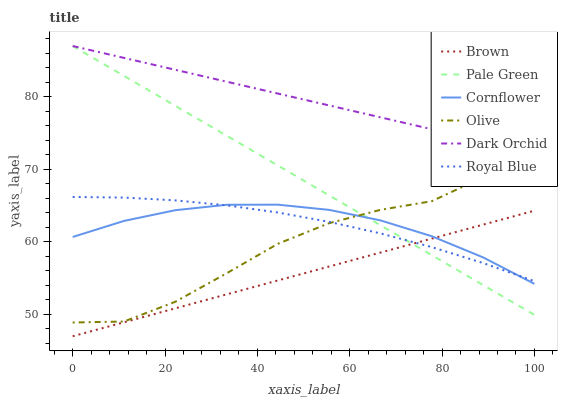Does Brown have the minimum area under the curve?
Answer yes or no. Yes. Does Dark Orchid have the maximum area under the curve?
Answer yes or no. Yes. Does Cornflower have the minimum area under the curve?
Answer yes or no. No. Does Cornflower have the maximum area under the curve?
Answer yes or no. No. Is Brown the smoothest?
Answer yes or no. Yes. Is Olive the roughest?
Answer yes or no. Yes. Is Cornflower the smoothest?
Answer yes or no. No. Is Cornflower the roughest?
Answer yes or no. No. Does Brown have the lowest value?
Answer yes or no. Yes. Does Cornflower have the lowest value?
Answer yes or no. No. Does Pale Green have the highest value?
Answer yes or no. Yes. Does Cornflower have the highest value?
Answer yes or no. No. Is Brown less than Olive?
Answer yes or no. Yes. Is Dark Orchid greater than Brown?
Answer yes or no. Yes. Does Royal Blue intersect Cornflower?
Answer yes or no. Yes. Is Royal Blue less than Cornflower?
Answer yes or no. No. Is Royal Blue greater than Cornflower?
Answer yes or no. No. Does Brown intersect Olive?
Answer yes or no. No. 